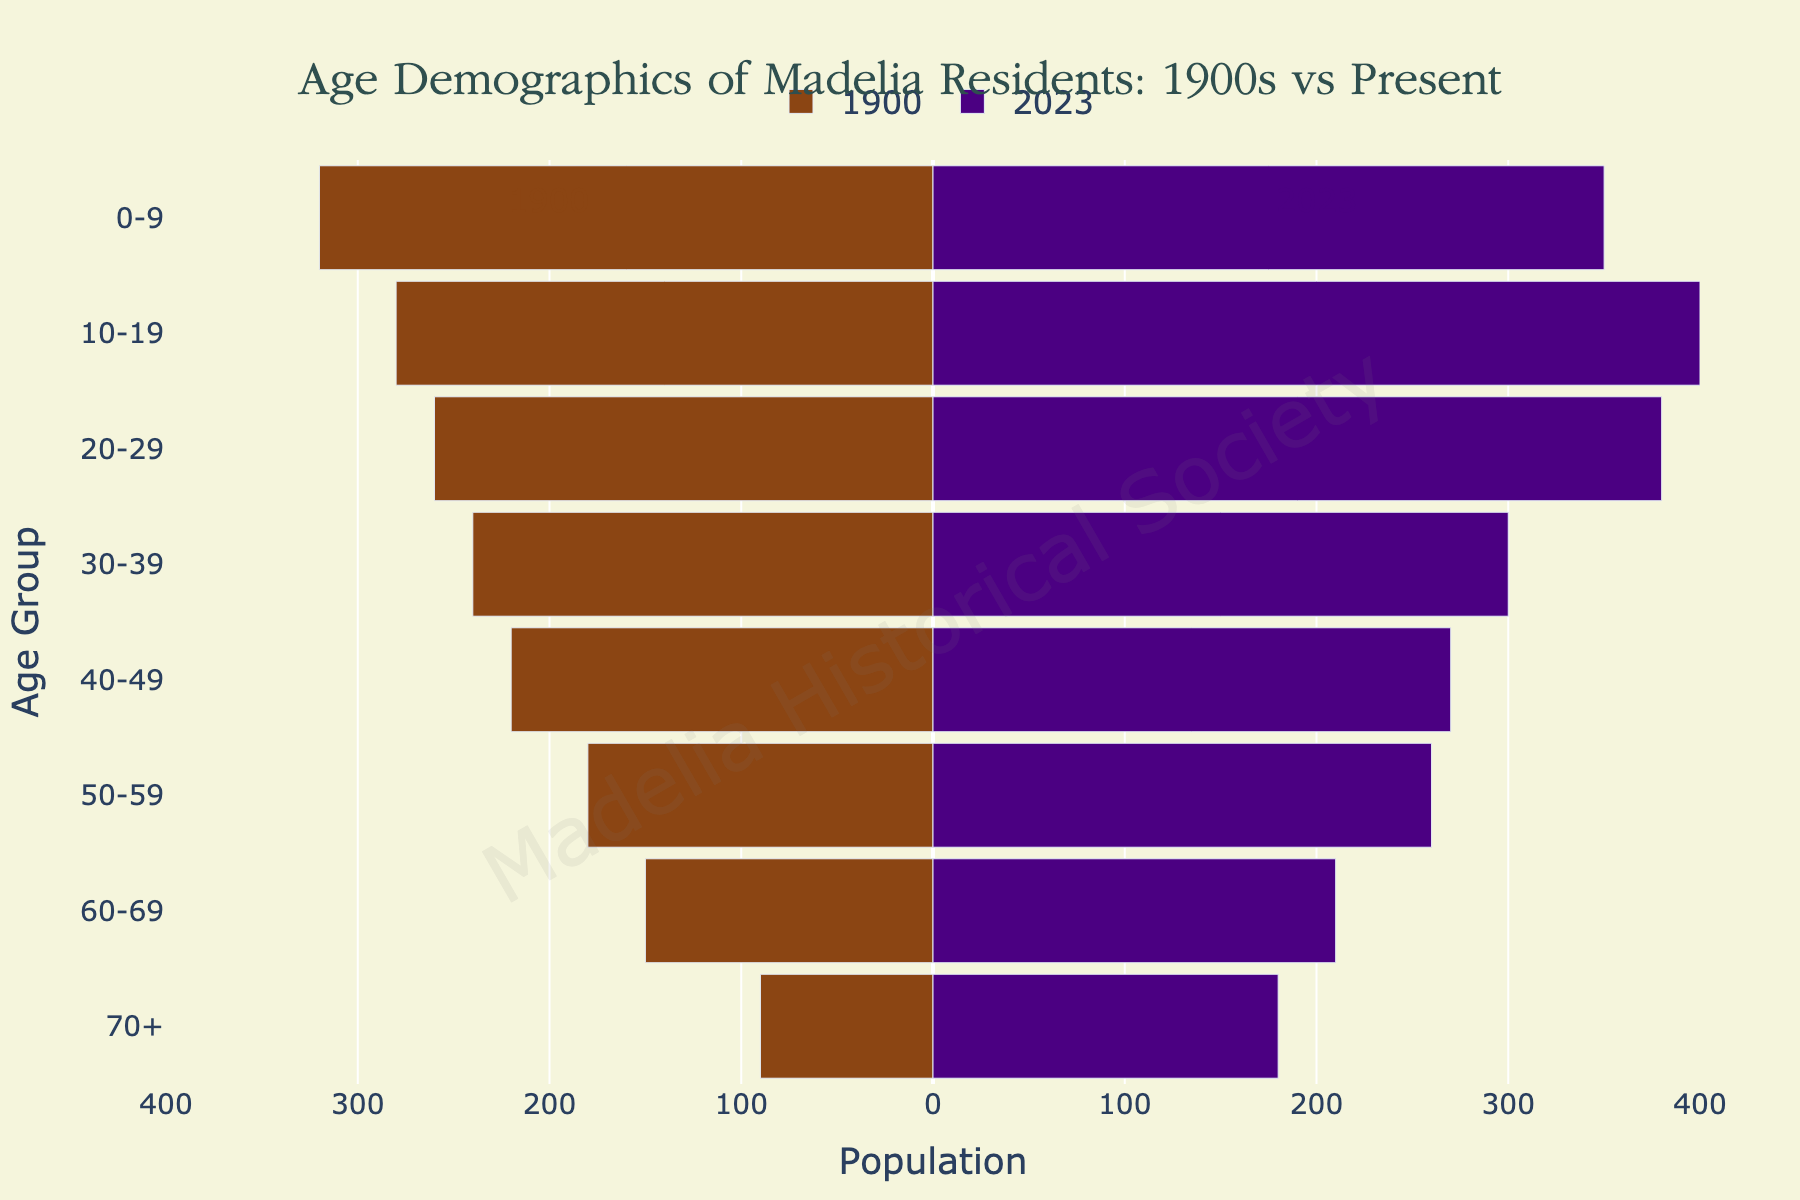How has the population of the 0-9 age group changed from 1900 to 2023? The diverging bar chart shows that the population of the 0-9 age group in 1900 was 320 and in 2023 it is 350. The change can be calculated as 350 - 320 = 30.
Answer: Increased by 30 Which age group experienced the largest increase in population from 1900 to 2023? To determine this, we need to compare the differences in population for each age group between 1900 and 2023. The differences are: 0-9 (350-320=30), 10-19 (400-280=120), 20-29 (380-260=120), 30-39 (300-240=60), 40-49 (270-220=50), 50-59 (260-180=80), 60-69 (210-150=60), 70+ (180-90=90). The largest increase is in the 10-19 and 20-29 age groups.
Answer: 10-19 and 20-29 What is the total population across all age groups for the year 2023? Add the population values for all age groups in 2023: 350 + 400 + 380 + 300 + 270 + 260 + 210 + 180 = 2350.
Answer: 2350 Compare the population of the 50-59 age group in 1900 and 2023. Which year had more people in this age group? The population for the 50-59 age group in 1900 was 180 and in 2023 it is 260. By comparing these numbers, we can see that 2023 had more people in this age group.
Answer: 2023 What can you say about the trend in the population of seniors aged 70+ from 1900 to 2023? The population of the 70+ age group in 1900 was 90 and in 2023 it is 180. The population has doubled, indicating an increasing trend in the number of seniors.
Answer: Increasing trend Between the 20-29 and 30-39 age groups, which group had a higher population in 1900? In 1900, the population of the 20-29 age group was 260, whereas the 30-39 age group had 240. The 20-29 age group had a higher population.
Answer: 20-29 Calculate the average population for the age groups in the year 1900. Sum the population of all age groups in 1900: 320 + 280 + 260 + 240 + 220 + 180 + 150 + 90 = 1740. There are 8 age groups, so the average population is 1740/8 = 217.5.
Answer: 217.5 Which age group has a larger difference in population when comparing 1900 to 2023: the 0-9 or 70+ age group? Calculate the difference for each age group: the 0-9 group changed by 350 - 320 = 30, and the 70+ group changed by 180 - 90 = 90. The 70+ age group has a larger difference.
Answer: 70+ 